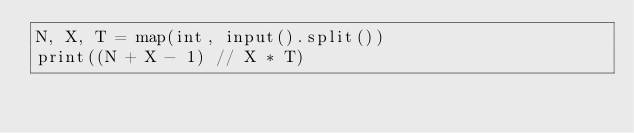<code> <loc_0><loc_0><loc_500><loc_500><_Python_>N, X, T = map(int, input().split())
print((N + X - 1) // X * T)
</code> 